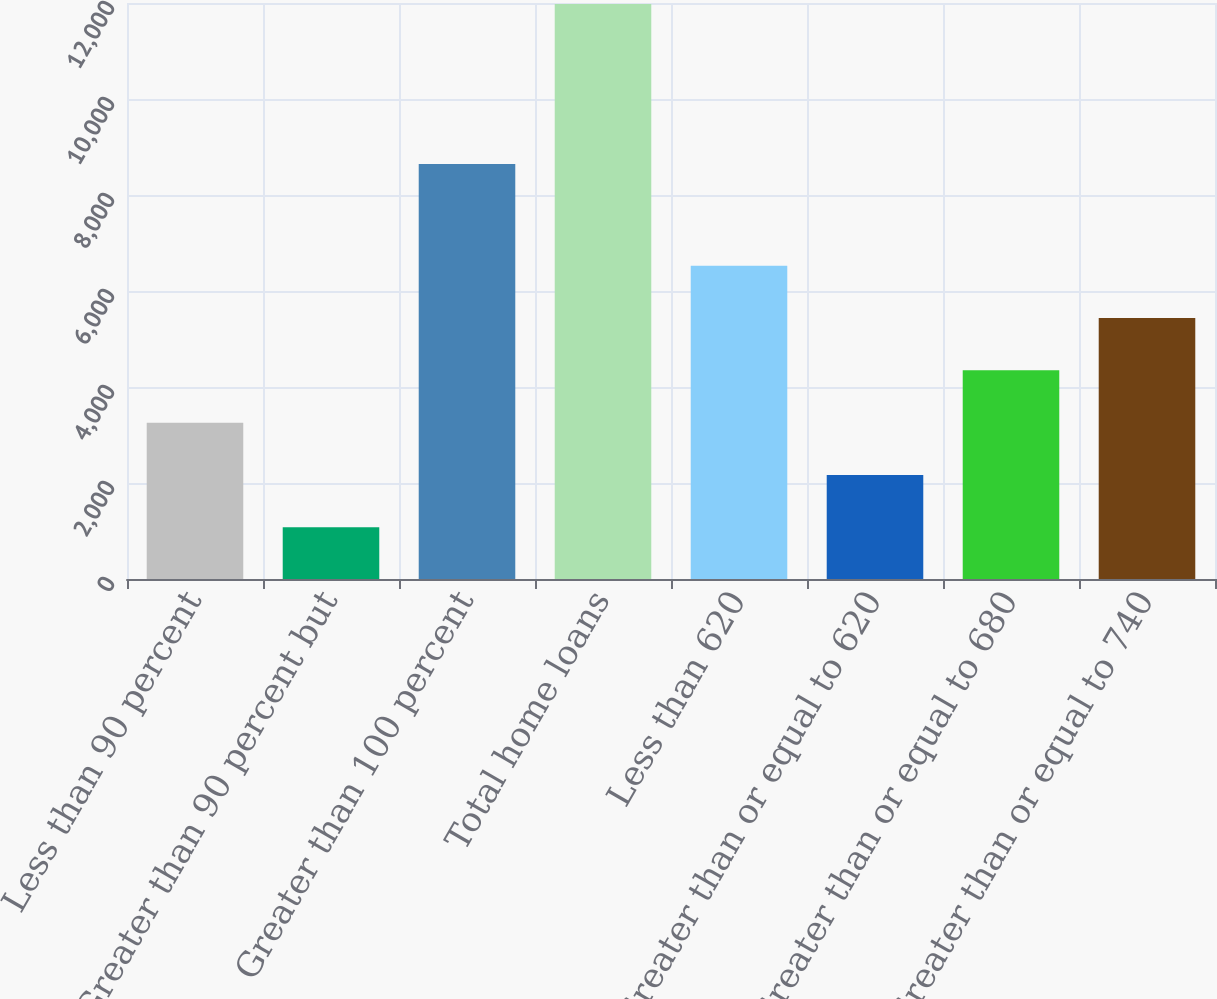Convert chart. <chart><loc_0><loc_0><loc_500><loc_500><bar_chart><fcel>Less than 90 percent<fcel>Greater than 90 percent but<fcel>Greater than 100 percent<fcel>Total home loans<fcel>Less than 620<fcel>Greater than or equal to 620<fcel>Greater than or equal to 680<fcel>Greater than or equal to 740<nl><fcel>3257.2<fcel>1077<fcel>8648<fcel>11978<fcel>6527.5<fcel>2167.1<fcel>4347.3<fcel>5437.4<nl></chart> 